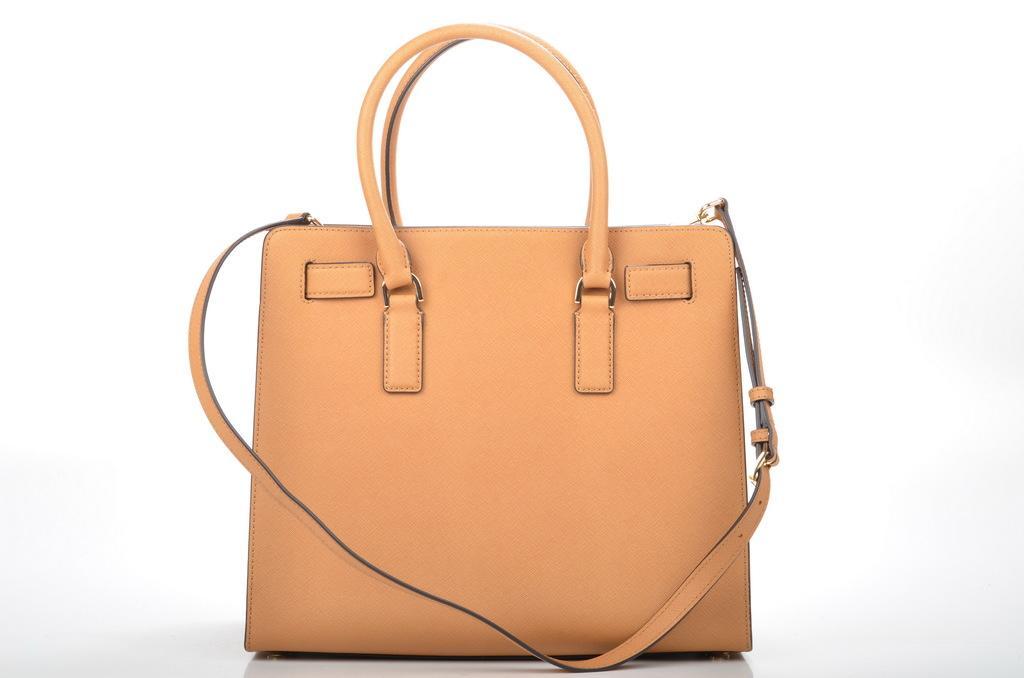Please provide a concise description of this image. There is a handbag. 